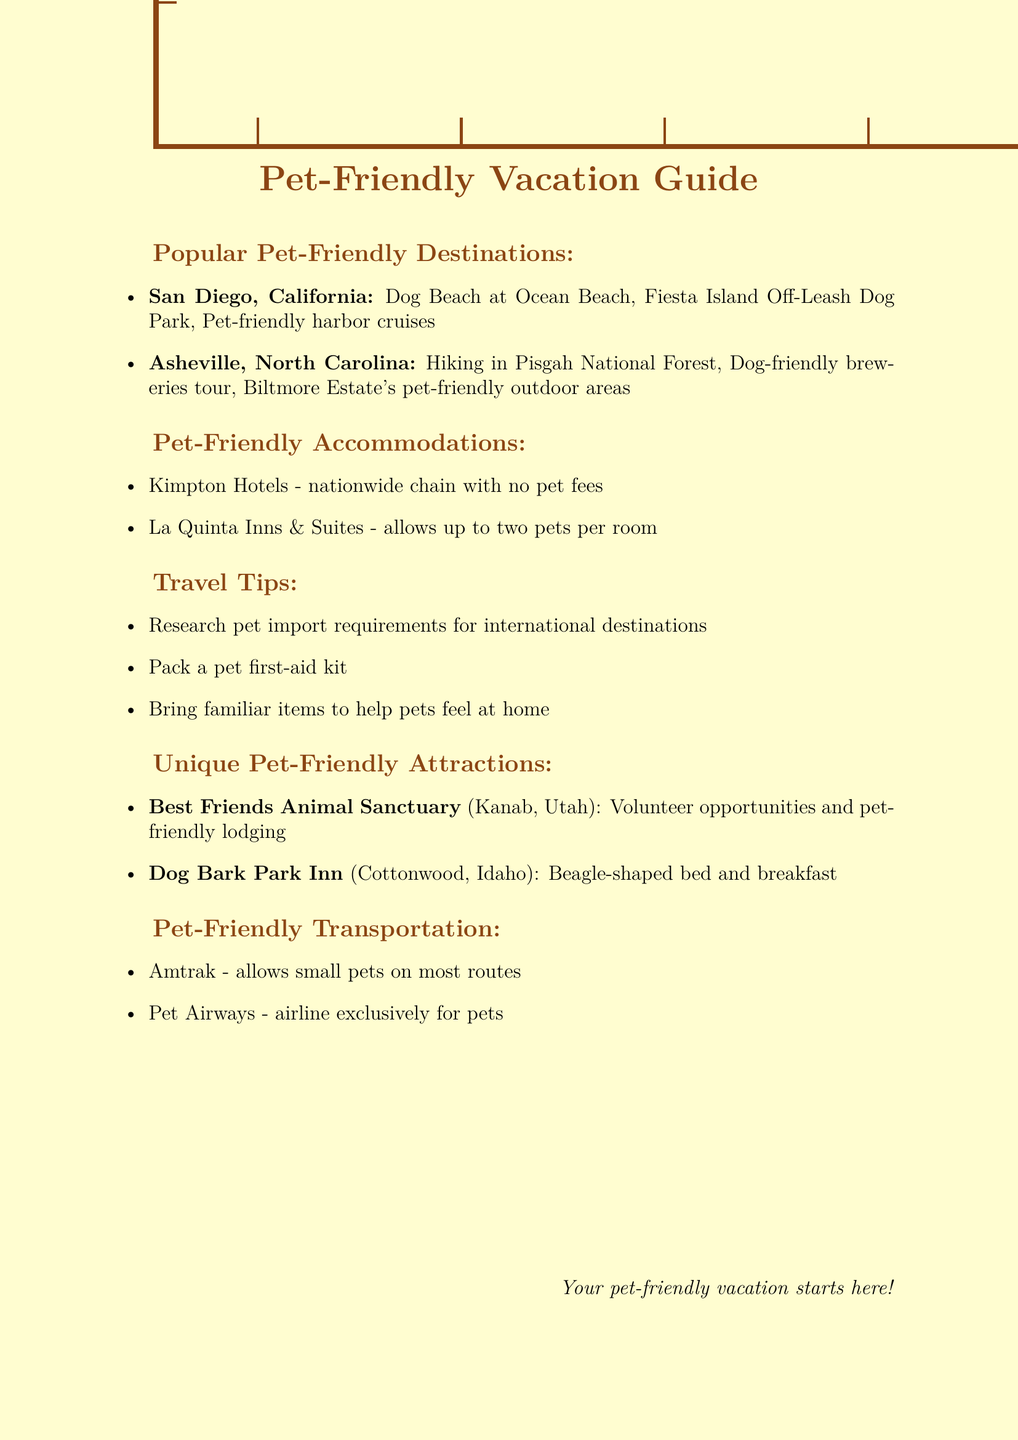What is one activity in San Diego? One of the activities listed for San Diego is Dog Beach at Ocean Beach.
Answer: Dog Beach at Ocean Beach What is the pet-friendly accommodation mentioned nationally? Kimpton Hotels is a nationwide chain mentioned in the document that has no pet fees.
Answer: Kimpton Hotels How many pets can La Quinta Inns & Suites accommodate? The document states that La Quinta Inns & Suites allows up to two pets per room.
Answer: Two pets What unique attraction is located in Kanab, Utah? The unique attraction mentioned in Kanab, Utah is Best Friends Animal Sanctuary.
Answer: Best Friends Animal Sanctuary Which transportation option allows small pets? Amtrak is listed as a transportation option that allows small pets on most routes.
Answer: Amtrak What should be included in a pet first-aid kit? A pet first-aid kit is a travel tip suggested in the document but specifics are not provided.
Answer: N/A Which activity involves a tour of breweries? The document mentions a dog-friendly breweries tour in Asheville, North Carolina.
Answer: Dog-friendly breweries tour What is the description of Dog Bark Park Inn? Dog Bark Park Inn is described as a Beagle-shaped bed and breakfast in the document.
Answer: Beagle-shaped bed and breakfast What city offers Fiesta Island Off-Leash Dog Park? Fiesta Island Off-Leash Dog Park is located in San Diego, California.
Answer: San Diego 